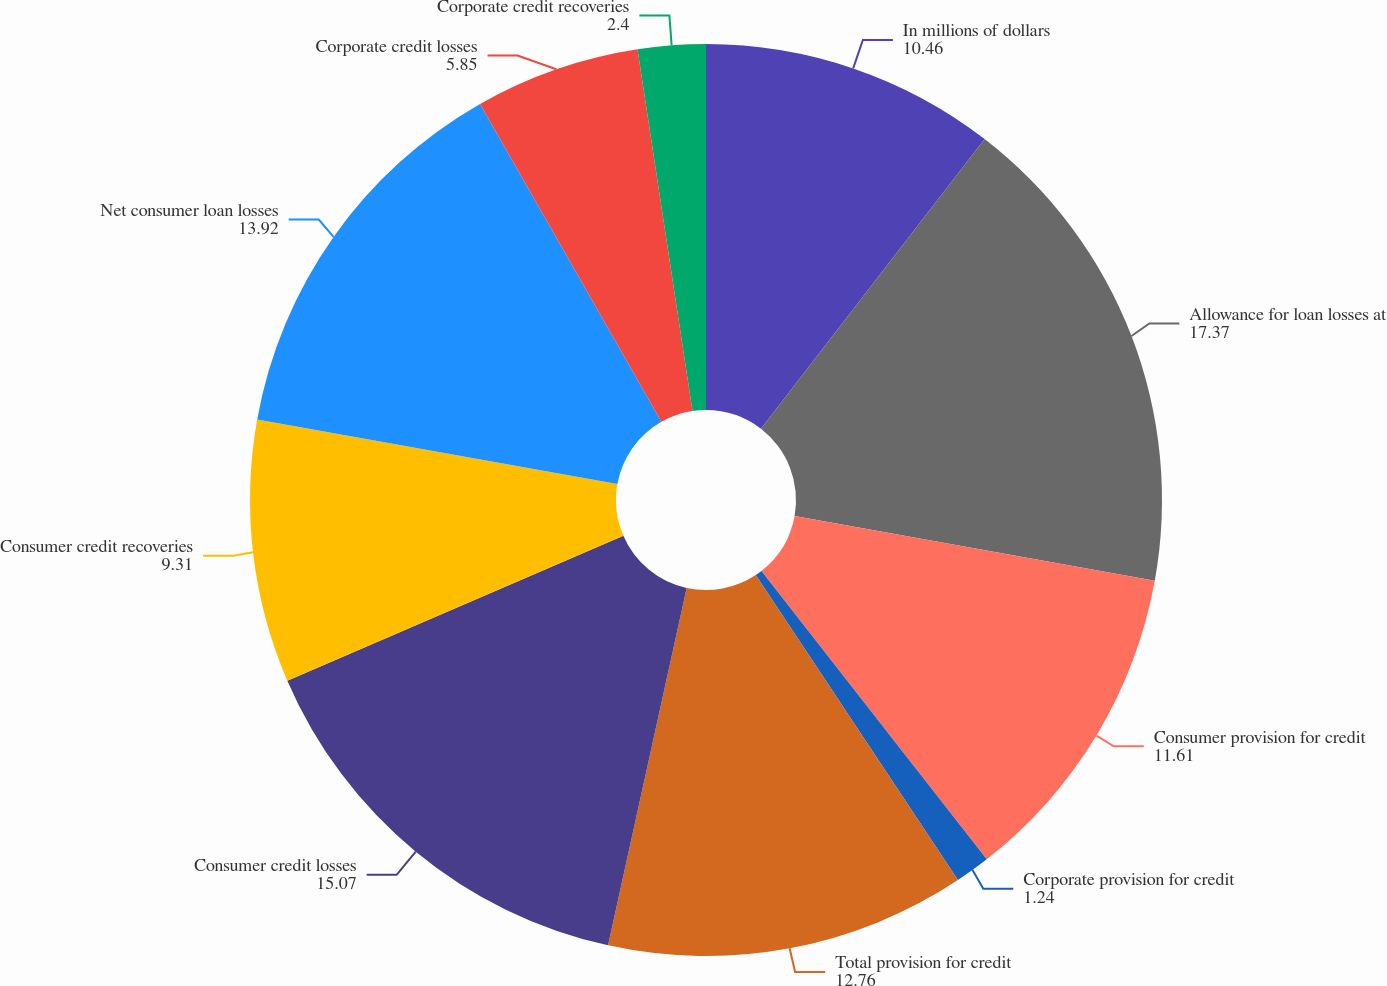Convert chart to OTSL. <chart><loc_0><loc_0><loc_500><loc_500><pie_chart><fcel>In millions of dollars<fcel>Allowance for loan losses at<fcel>Consumer provision for credit<fcel>Corporate provision for credit<fcel>Total provision for credit<fcel>Consumer credit losses<fcel>Consumer credit recoveries<fcel>Net consumer loan losses<fcel>Corporate credit losses<fcel>Corporate credit recoveries<nl><fcel>10.46%<fcel>17.37%<fcel>11.61%<fcel>1.24%<fcel>12.76%<fcel>15.07%<fcel>9.31%<fcel>13.92%<fcel>5.85%<fcel>2.4%<nl></chart> 